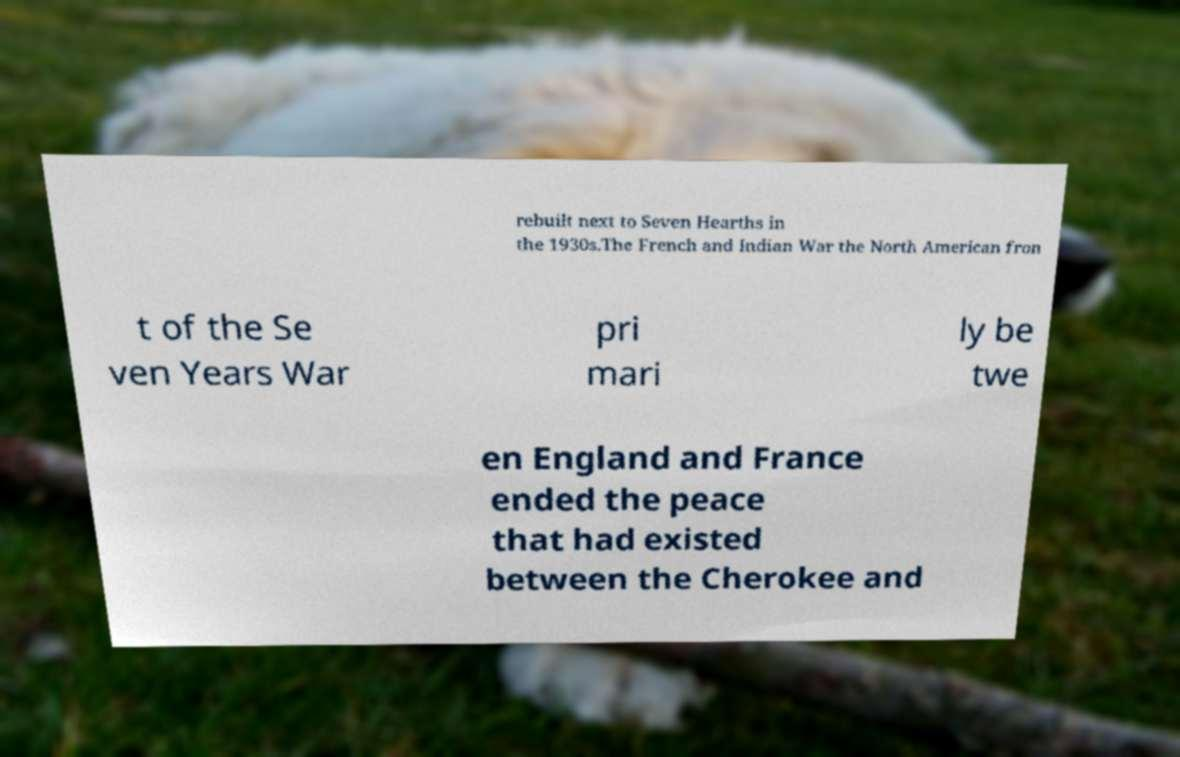Can you accurately transcribe the text from the provided image for me? rebuilt next to Seven Hearths in the 1930s.The French and Indian War the North American fron t of the Se ven Years War pri mari ly be twe en England and France ended the peace that had existed between the Cherokee and 